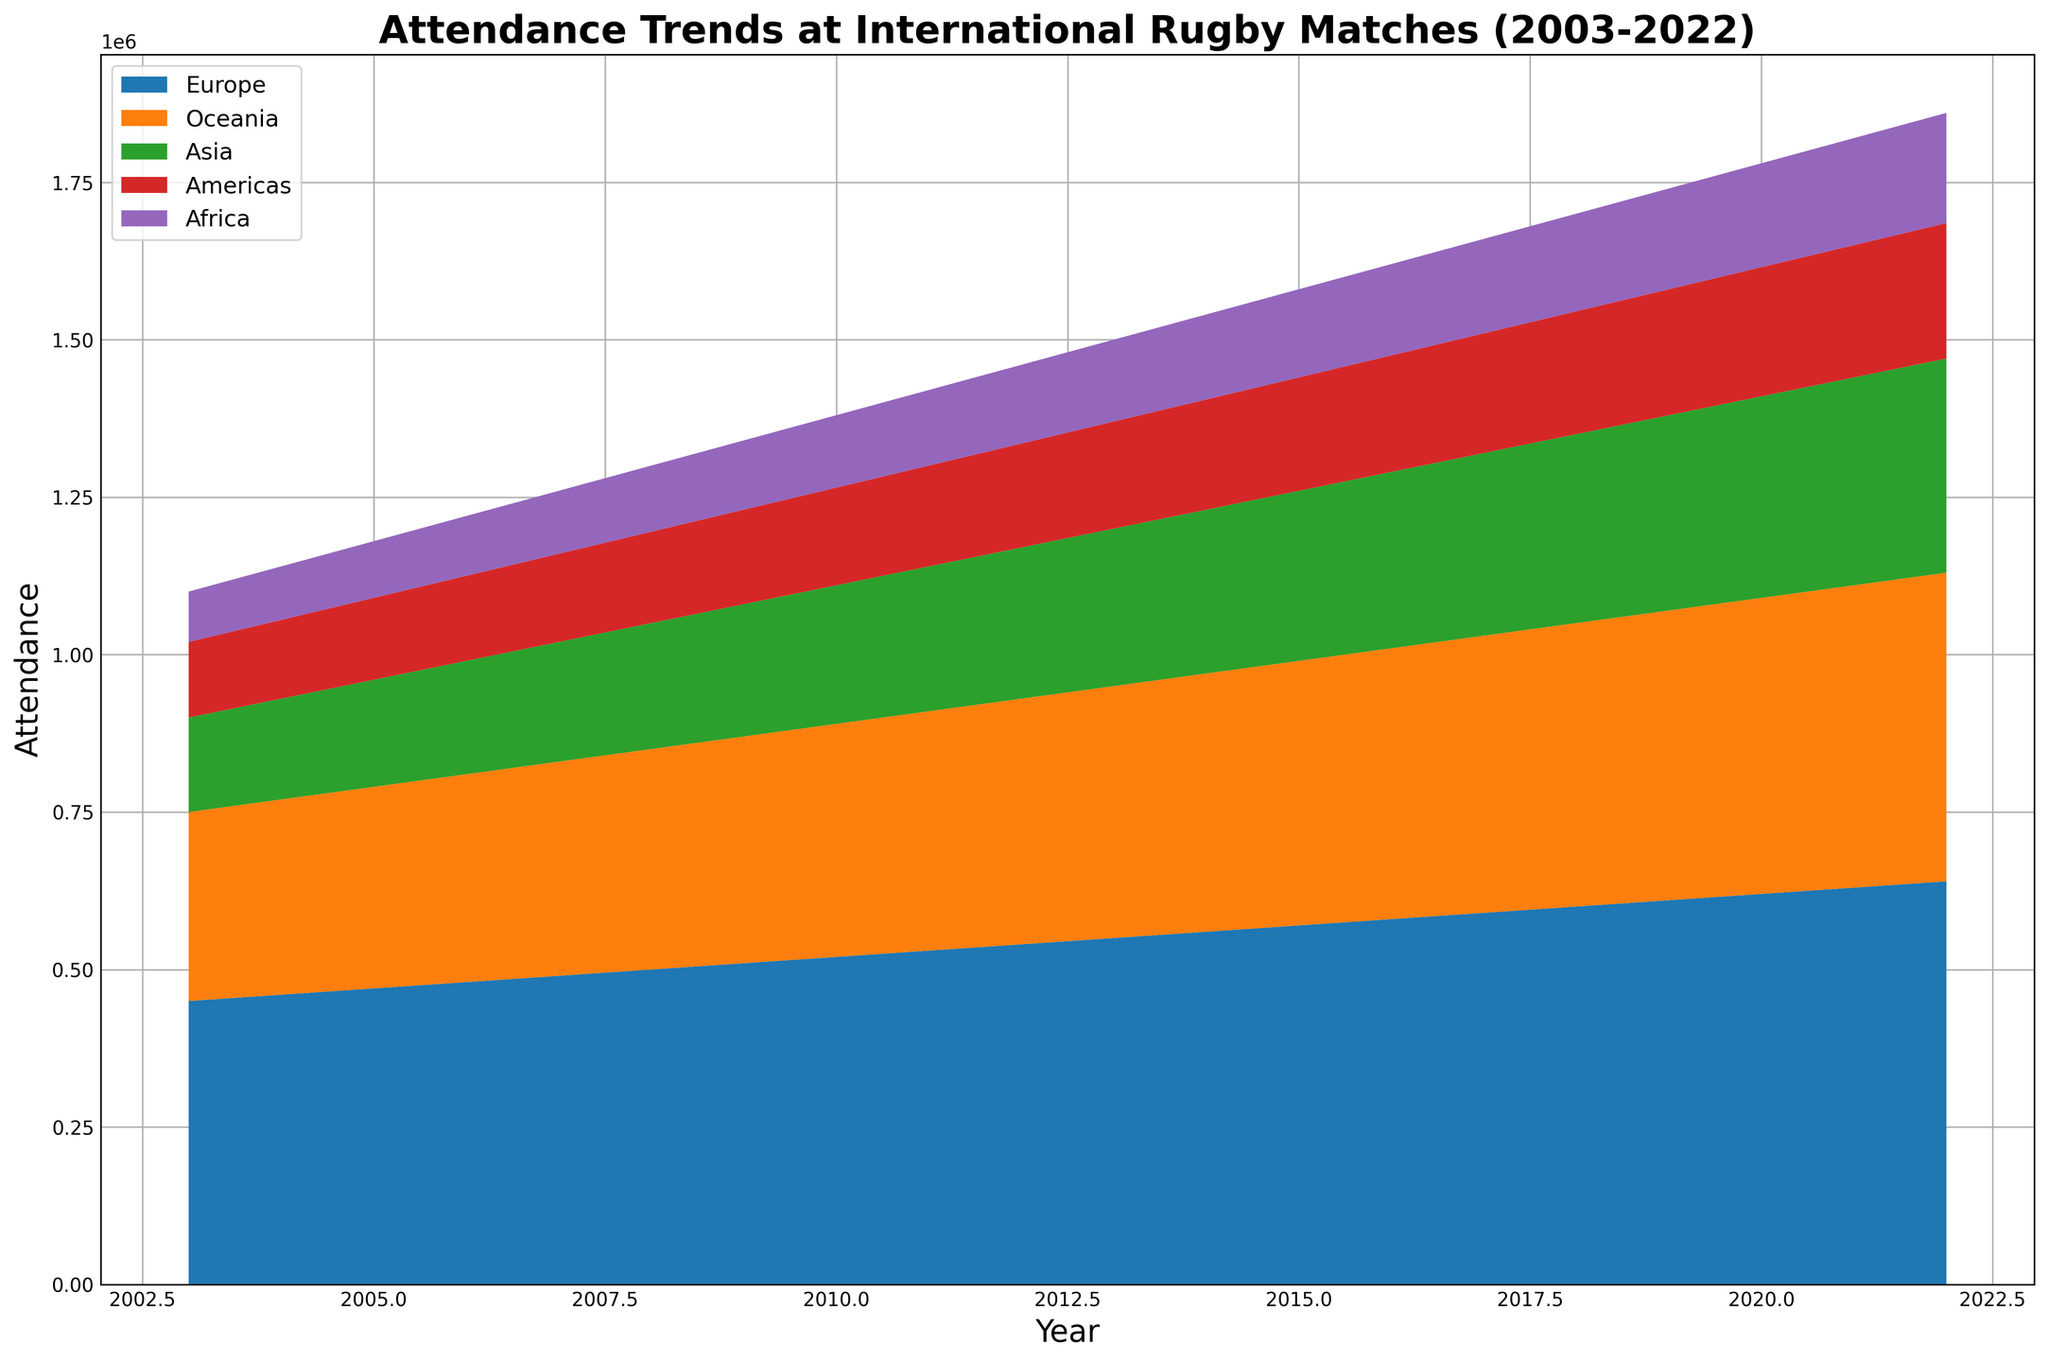What continent had the highest attendance around 2015? Looking at the figure, you can see that Europe (represented by the topmost color) consistently has higher attendance over the years. Around 2015, Europe remains the tallest layer in the area chart.
Answer: Europe Which continent showed the greatest increase in attendance from 2003 to 2022? By observing the stacking area's expansion for each continent, it's clear that Europe exhibits the most significant growth as it started highest and ended higher than others.
Answer: Europe Did any continent show a decrease in attendance over the given period? The visual data shows every continent's attendance growing without any dips or decreases in their areas from 2003 to 2022.
Answer: No How does the attendance in Africa in 2022 compare to attendance in Oceania in 2003? To compare, find the height of Africa's color in 2022 and compare it to the height of Oceania's color in 2003. Africa’s attendance in 2022 is higher based on the visual height of the area.
Answer: Africa’s attendance in 2022 is higher What was the total attendance across all continents in 2010? To find the total, sum up the attendance values for all continents in the year 2010. Summing 520,000 (Europe) + 370,000 (Oceania) + 220,000 (Asia) + 155,000 (Americas) + 115,000 (Africa), the total is 1,380,000.
Answer: 1,380,000 Which continent had the smallest attendance throughout the years, and did it ever surpass any other continent's annual attendance? Look at the bottommost layer representing Africa. Its visual height suggests it had the smallest attendance, and it never visually overlaps or exceeds the layers above it.
Answer: Africa, and it never surpassed others What's the average attendance for Oceania during the first five years? Sum the attendance values for Oceania from 2003 to 2007 and then divide by 5. So, (300,000 + 310,000 + 320,000 + 330,000 + 340,000) = 1,600,000, and 1,600,000 / 5 = 320,000.
Answer: 320,000 Which two continents had the closest attendance numbers in 2020? In 2020, identify the two continents with areas closest in height. Observing the chart, the Americas and Africa have visually closer areas.
Answer: Americas and Africa What was the combined attendance for Asia and the Americas in 2018? Sum the attendance values of Asia and the Americas for the year 2018. That's 300,000 (Asia) + 195,000 (Americas) = 495,000.
Answer: 495,000 How does the growth rate of attendance in Asia compare to that of the Americas from 2008 to 2018? Calculate the increase for each continent over the given period. For Asia, it’s 300,000 - 200,000 = 100,000, and for the Americas, it’s 195,000 - 145,000 = 50,000. Asia’s growth rate is quicker.
Answer: Asia had a faster growth rate 